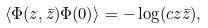Convert formula to latex. <formula><loc_0><loc_0><loc_500><loc_500>\langle \Phi ( z , \bar { z } ) \Phi ( 0 ) \rangle = - \log ( c z \bar { z } ) ,</formula> 